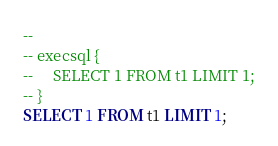Convert code to text. <code><loc_0><loc_0><loc_500><loc_500><_SQL_>-- 
-- execsql {
--     SELECT 1 FROM t1 LIMIT 1;
-- }
SELECT 1 FROM t1 LIMIT 1;</code> 